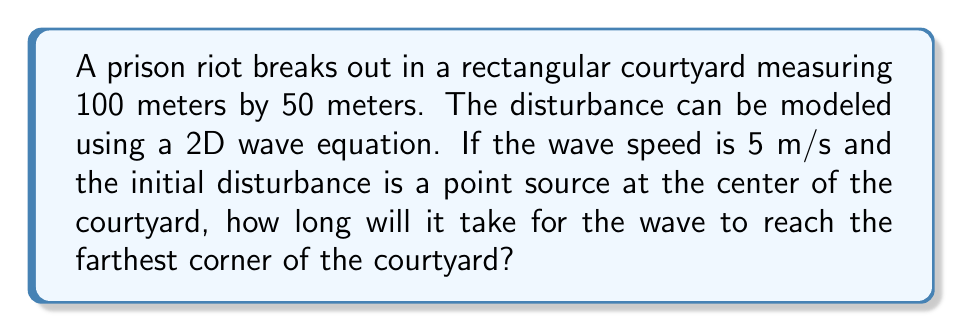Show me your answer to this math problem. To solve this problem, we'll follow these steps:

1) First, we need to identify the farthest point from the center of the courtyard. This will be one of the corners.

2) The courtyard is rectangular, so we can use the Pythagorean theorem to calculate the distance from the center to a corner.

3) Let's set up our coordinate system with the origin at the center of the courtyard. The corners will be at (±50, ±25).

4) The distance $d$ from the center (0,0) to a corner (50,25) is:

   $$d = \sqrt{50^2 + 25^2} = \sqrt{3125} = 25\sqrt{5}$$ meters

5) Now that we have the distance, we can use the wave speed equation:

   $$\text{speed} = \frac{\text{distance}}{\text{time}}$$

6) Rearranging this equation to solve for time:

   $$\text{time} = \frac{\text{distance}}{\text{speed}}$$

7) Plugging in our values:

   $$\text{time} = \frac{25\sqrt{5}}{5} = 5\sqrt{5}$$ seconds

Therefore, it will take $5\sqrt{5}$ seconds for the wave to reach the farthest corner of the courtyard.
Answer: $5\sqrt{5}$ seconds 